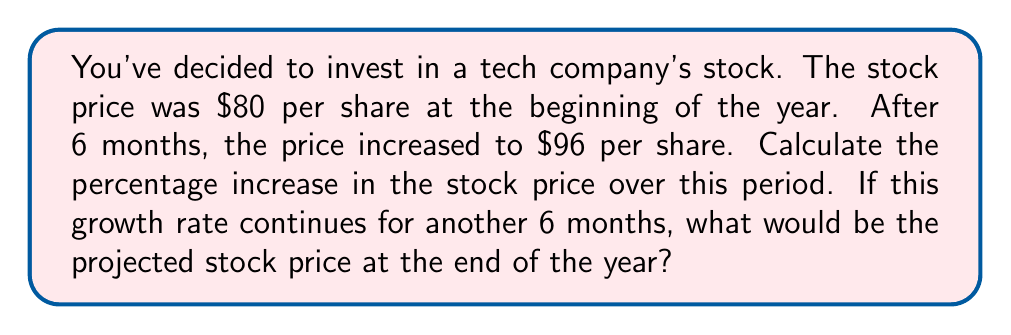Show me your answer to this math problem. Let's break this down step-by-step:

1. Calculate the percentage increase for the first 6 months:

   Initial price: $80
   Price after 6 months: $96

   To calculate the percentage increase, we use the formula:
   
   $$ \text{Percentage Increase} = \frac{\text{Increase}}{\text{Original Amount}} \times 100\% $$

   $$ \text{Percentage Increase} = \frac{96 - 80}{80} \times 100\% = \frac{16}{80} \times 100\% = 0.2 \times 100\% = 20\% $$

2. Project the stock price for the next 6 months:

   If the growth rate continues, we expect another 20% increase in the second half of the year.
   
   To calculate this, we use the formula:
   
   $$ \text{New Price} = \text{Current Price} \times (1 + \text{Growth Rate}) $$

   $$ \text{New Price} = 96 \times (1 + 0.20) = 96 \times 1.20 = 115.20 $$

Therefore, if the growth rate continues, the projected stock price at the end of the year would be $115.20 per share.
Answer: The percentage increase in the stock price over the first 6 months is 20%. The projected stock price at the end of the year, assuming the same growth rate continues, would be $115.20 per share. 